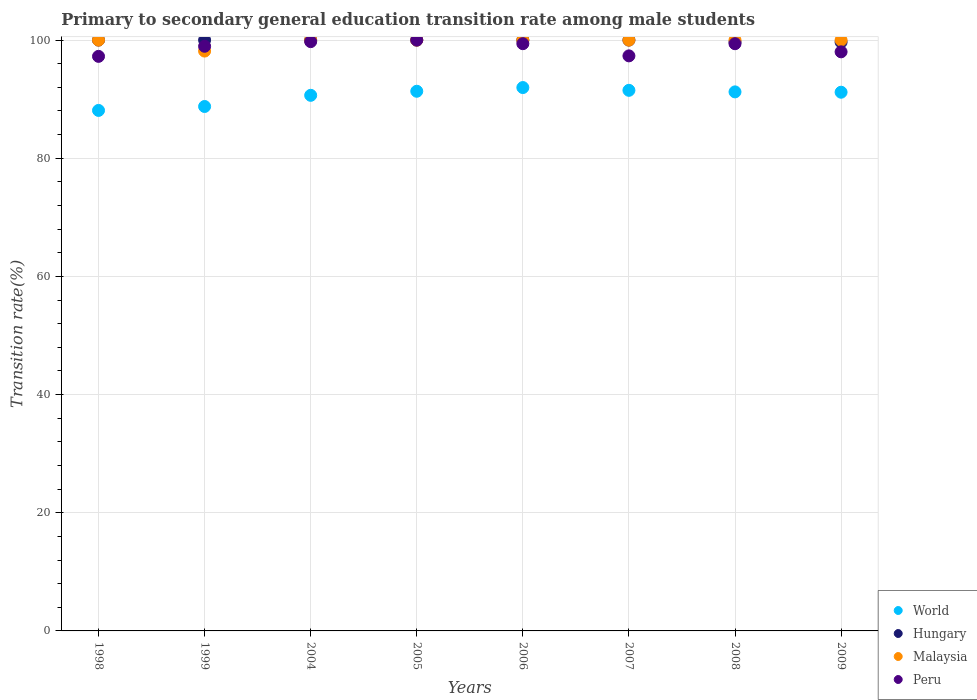Is the number of dotlines equal to the number of legend labels?
Offer a very short reply. Yes. Across all years, what is the maximum transition rate in World?
Your response must be concise. 91.97. Across all years, what is the minimum transition rate in World?
Your answer should be very brief. 88.1. What is the total transition rate in Malaysia in the graph?
Your answer should be very brief. 798.14. What is the difference between the transition rate in Hungary in 1998 and that in 2009?
Your answer should be compact. 0.35. What is the difference between the transition rate in Malaysia in 2007 and the transition rate in Hungary in 2008?
Keep it short and to the point. 0.32. What is the average transition rate in Hungary per year?
Provide a short and direct response. 99.92. In the year 2004, what is the difference between the transition rate in World and transition rate in Malaysia?
Provide a short and direct response. -9.35. In how many years, is the transition rate in World greater than 40 %?
Keep it short and to the point. 8. What is the ratio of the transition rate in Hungary in 1998 to that in 2009?
Offer a very short reply. 1. Is the difference between the transition rate in World in 2004 and 2006 greater than the difference between the transition rate in Malaysia in 2004 and 2006?
Your answer should be very brief. No. What is the difference between the highest and the second highest transition rate in Peru?
Make the answer very short. 0.26. What is the difference between the highest and the lowest transition rate in World?
Make the answer very short. 3.87. Is it the case that in every year, the sum of the transition rate in Peru and transition rate in Malaysia  is greater than the sum of transition rate in Hungary and transition rate in World?
Give a very brief answer. No. Is the transition rate in World strictly greater than the transition rate in Malaysia over the years?
Your answer should be very brief. No. How many dotlines are there?
Ensure brevity in your answer.  4. How many years are there in the graph?
Your answer should be compact. 8. Does the graph contain any zero values?
Provide a succinct answer. No. Does the graph contain grids?
Ensure brevity in your answer.  Yes. Where does the legend appear in the graph?
Offer a very short reply. Bottom right. What is the title of the graph?
Provide a short and direct response. Primary to secondary general education transition rate among male students. What is the label or title of the X-axis?
Your response must be concise. Years. What is the label or title of the Y-axis?
Provide a succinct answer. Transition rate(%). What is the Transition rate(%) of World in 1998?
Your answer should be very brief. 88.1. What is the Transition rate(%) in Peru in 1998?
Make the answer very short. 97.25. What is the Transition rate(%) of World in 1999?
Keep it short and to the point. 88.76. What is the Transition rate(%) in Malaysia in 1999?
Offer a terse response. 98.14. What is the Transition rate(%) of Peru in 1999?
Your response must be concise. 98.95. What is the Transition rate(%) in World in 2004?
Your answer should be very brief. 90.65. What is the Transition rate(%) in Hungary in 2004?
Make the answer very short. 100. What is the Transition rate(%) of Malaysia in 2004?
Your answer should be very brief. 100. What is the Transition rate(%) in Peru in 2004?
Your answer should be compact. 99.74. What is the Transition rate(%) in World in 2005?
Provide a short and direct response. 91.34. What is the Transition rate(%) in Malaysia in 2005?
Your response must be concise. 100. What is the Transition rate(%) of Peru in 2005?
Your answer should be very brief. 100. What is the Transition rate(%) of World in 2006?
Offer a very short reply. 91.97. What is the Transition rate(%) in Peru in 2006?
Make the answer very short. 99.39. What is the Transition rate(%) of World in 2007?
Your answer should be compact. 91.5. What is the Transition rate(%) in Hungary in 2007?
Your response must be concise. 100. What is the Transition rate(%) of Malaysia in 2007?
Give a very brief answer. 100. What is the Transition rate(%) in Peru in 2007?
Ensure brevity in your answer.  97.33. What is the Transition rate(%) of World in 2008?
Your answer should be compact. 91.23. What is the Transition rate(%) of Hungary in 2008?
Provide a short and direct response. 99.68. What is the Transition rate(%) in Peru in 2008?
Offer a terse response. 99.39. What is the Transition rate(%) of World in 2009?
Your answer should be very brief. 91.18. What is the Transition rate(%) of Hungary in 2009?
Give a very brief answer. 99.65. What is the Transition rate(%) of Malaysia in 2009?
Your response must be concise. 100. What is the Transition rate(%) of Peru in 2009?
Your answer should be compact. 98.01. Across all years, what is the maximum Transition rate(%) of World?
Offer a very short reply. 91.97. Across all years, what is the minimum Transition rate(%) of World?
Your answer should be very brief. 88.1. Across all years, what is the minimum Transition rate(%) in Hungary?
Provide a short and direct response. 99.65. Across all years, what is the minimum Transition rate(%) of Malaysia?
Ensure brevity in your answer.  98.14. Across all years, what is the minimum Transition rate(%) in Peru?
Your response must be concise. 97.25. What is the total Transition rate(%) in World in the graph?
Ensure brevity in your answer.  724.72. What is the total Transition rate(%) in Hungary in the graph?
Your answer should be compact. 799.33. What is the total Transition rate(%) in Malaysia in the graph?
Your answer should be very brief. 798.14. What is the total Transition rate(%) in Peru in the graph?
Keep it short and to the point. 790.06. What is the difference between the Transition rate(%) of World in 1998 and that in 1999?
Ensure brevity in your answer.  -0.67. What is the difference between the Transition rate(%) in Malaysia in 1998 and that in 1999?
Offer a very short reply. 1.86. What is the difference between the Transition rate(%) in Peru in 1998 and that in 1999?
Provide a short and direct response. -1.71. What is the difference between the Transition rate(%) in World in 1998 and that in 2004?
Offer a very short reply. -2.56. What is the difference between the Transition rate(%) in Peru in 1998 and that in 2004?
Provide a short and direct response. -2.49. What is the difference between the Transition rate(%) in World in 1998 and that in 2005?
Offer a very short reply. -3.24. What is the difference between the Transition rate(%) in Hungary in 1998 and that in 2005?
Ensure brevity in your answer.  0. What is the difference between the Transition rate(%) in Malaysia in 1998 and that in 2005?
Keep it short and to the point. 0. What is the difference between the Transition rate(%) in Peru in 1998 and that in 2005?
Offer a terse response. -2.75. What is the difference between the Transition rate(%) in World in 1998 and that in 2006?
Offer a terse response. -3.87. What is the difference between the Transition rate(%) of Peru in 1998 and that in 2006?
Give a very brief answer. -2.15. What is the difference between the Transition rate(%) of World in 1998 and that in 2007?
Ensure brevity in your answer.  -3.4. What is the difference between the Transition rate(%) in Hungary in 1998 and that in 2007?
Provide a succinct answer. 0. What is the difference between the Transition rate(%) of Peru in 1998 and that in 2007?
Your answer should be very brief. -0.08. What is the difference between the Transition rate(%) of World in 1998 and that in 2008?
Your answer should be very brief. -3.14. What is the difference between the Transition rate(%) in Hungary in 1998 and that in 2008?
Offer a very short reply. 0.32. What is the difference between the Transition rate(%) of Peru in 1998 and that in 2008?
Provide a succinct answer. -2.14. What is the difference between the Transition rate(%) in World in 1998 and that in 2009?
Your answer should be very brief. -3.08. What is the difference between the Transition rate(%) in Hungary in 1998 and that in 2009?
Give a very brief answer. 0.35. What is the difference between the Transition rate(%) of Peru in 1998 and that in 2009?
Your answer should be very brief. -0.77. What is the difference between the Transition rate(%) in World in 1999 and that in 2004?
Provide a succinct answer. -1.89. What is the difference between the Transition rate(%) in Malaysia in 1999 and that in 2004?
Ensure brevity in your answer.  -1.86. What is the difference between the Transition rate(%) of Peru in 1999 and that in 2004?
Provide a succinct answer. -0.79. What is the difference between the Transition rate(%) in World in 1999 and that in 2005?
Make the answer very short. -2.58. What is the difference between the Transition rate(%) in Malaysia in 1999 and that in 2005?
Provide a succinct answer. -1.86. What is the difference between the Transition rate(%) in Peru in 1999 and that in 2005?
Make the answer very short. -1.05. What is the difference between the Transition rate(%) of World in 1999 and that in 2006?
Keep it short and to the point. -3.2. What is the difference between the Transition rate(%) of Hungary in 1999 and that in 2006?
Ensure brevity in your answer.  0. What is the difference between the Transition rate(%) of Malaysia in 1999 and that in 2006?
Offer a very short reply. -1.86. What is the difference between the Transition rate(%) in Peru in 1999 and that in 2006?
Provide a short and direct response. -0.44. What is the difference between the Transition rate(%) in World in 1999 and that in 2007?
Ensure brevity in your answer.  -2.74. What is the difference between the Transition rate(%) in Hungary in 1999 and that in 2007?
Offer a terse response. 0. What is the difference between the Transition rate(%) in Malaysia in 1999 and that in 2007?
Your answer should be compact. -1.86. What is the difference between the Transition rate(%) of Peru in 1999 and that in 2007?
Provide a succinct answer. 1.62. What is the difference between the Transition rate(%) in World in 1999 and that in 2008?
Your answer should be compact. -2.47. What is the difference between the Transition rate(%) of Hungary in 1999 and that in 2008?
Your answer should be compact. 0.32. What is the difference between the Transition rate(%) in Malaysia in 1999 and that in 2008?
Keep it short and to the point. -1.86. What is the difference between the Transition rate(%) in Peru in 1999 and that in 2008?
Your response must be concise. -0.43. What is the difference between the Transition rate(%) in World in 1999 and that in 2009?
Your response must be concise. -2.41. What is the difference between the Transition rate(%) in Hungary in 1999 and that in 2009?
Keep it short and to the point. 0.35. What is the difference between the Transition rate(%) in Malaysia in 1999 and that in 2009?
Keep it short and to the point. -1.86. What is the difference between the Transition rate(%) of Peru in 1999 and that in 2009?
Your response must be concise. 0.94. What is the difference between the Transition rate(%) of World in 2004 and that in 2005?
Make the answer very short. -0.69. What is the difference between the Transition rate(%) of Hungary in 2004 and that in 2005?
Make the answer very short. 0. What is the difference between the Transition rate(%) of Malaysia in 2004 and that in 2005?
Provide a short and direct response. 0. What is the difference between the Transition rate(%) of Peru in 2004 and that in 2005?
Ensure brevity in your answer.  -0.26. What is the difference between the Transition rate(%) of World in 2004 and that in 2006?
Your answer should be compact. -1.31. What is the difference between the Transition rate(%) in Malaysia in 2004 and that in 2006?
Your answer should be compact. 0. What is the difference between the Transition rate(%) in Peru in 2004 and that in 2006?
Offer a terse response. 0.35. What is the difference between the Transition rate(%) of World in 2004 and that in 2007?
Give a very brief answer. -0.85. What is the difference between the Transition rate(%) in Hungary in 2004 and that in 2007?
Offer a terse response. 0. What is the difference between the Transition rate(%) of Malaysia in 2004 and that in 2007?
Offer a terse response. 0. What is the difference between the Transition rate(%) in Peru in 2004 and that in 2007?
Give a very brief answer. 2.41. What is the difference between the Transition rate(%) of World in 2004 and that in 2008?
Provide a succinct answer. -0.58. What is the difference between the Transition rate(%) in Hungary in 2004 and that in 2008?
Make the answer very short. 0.32. What is the difference between the Transition rate(%) of Malaysia in 2004 and that in 2008?
Provide a succinct answer. 0. What is the difference between the Transition rate(%) of Peru in 2004 and that in 2008?
Offer a very short reply. 0.35. What is the difference between the Transition rate(%) of World in 2004 and that in 2009?
Make the answer very short. -0.53. What is the difference between the Transition rate(%) in Hungary in 2004 and that in 2009?
Your response must be concise. 0.35. What is the difference between the Transition rate(%) of Peru in 2004 and that in 2009?
Make the answer very short. 1.73. What is the difference between the Transition rate(%) in World in 2005 and that in 2006?
Your answer should be compact. -0.63. What is the difference between the Transition rate(%) of Peru in 2005 and that in 2006?
Offer a very short reply. 0.61. What is the difference between the Transition rate(%) of World in 2005 and that in 2007?
Provide a short and direct response. -0.16. What is the difference between the Transition rate(%) of Hungary in 2005 and that in 2007?
Your answer should be very brief. 0. What is the difference between the Transition rate(%) in Peru in 2005 and that in 2007?
Make the answer very short. 2.67. What is the difference between the Transition rate(%) of World in 2005 and that in 2008?
Make the answer very short. 0.11. What is the difference between the Transition rate(%) in Hungary in 2005 and that in 2008?
Your response must be concise. 0.32. What is the difference between the Transition rate(%) of Malaysia in 2005 and that in 2008?
Your answer should be compact. 0. What is the difference between the Transition rate(%) of Peru in 2005 and that in 2008?
Offer a very short reply. 0.61. What is the difference between the Transition rate(%) of World in 2005 and that in 2009?
Give a very brief answer. 0.16. What is the difference between the Transition rate(%) in Hungary in 2005 and that in 2009?
Your answer should be very brief. 0.35. What is the difference between the Transition rate(%) in Peru in 2005 and that in 2009?
Provide a succinct answer. 1.99. What is the difference between the Transition rate(%) in World in 2006 and that in 2007?
Provide a short and direct response. 0.47. What is the difference between the Transition rate(%) of Malaysia in 2006 and that in 2007?
Make the answer very short. 0. What is the difference between the Transition rate(%) in Peru in 2006 and that in 2007?
Your answer should be very brief. 2.06. What is the difference between the Transition rate(%) of World in 2006 and that in 2008?
Make the answer very short. 0.73. What is the difference between the Transition rate(%) of Hungary in 2006 and that in 2008?
Give a very brief answer. 0.32. What is the difference between the Transition rate(%) in Malaysia in 2006 and that in 2008?
Your answer should be very brief. 0. What is the difference between the Transition rate(%) of Peru in 2006 and that in 2008?
Provide a succinct answer. 0. What is the difference between the Transition rate(%) of World in 2006 and that in 2009?
Your response must be concise. 0.79. What is the difference between the Transition rate(%) in Hungary in 2006 and that in 2009?
Ensure brevity in your answer.  0.35. What is the difference between the Transition rate(%) of Malaysia in 2006 and that in 2009?
Your answer should be very brief. 0. What is the difference between the Transition rate(%) in Peru in 2006 and that in 2009?
Provide a succinct answer. 1.38. What is the difference between the Transition rate(%) in World in 2007 and that in 2008?
Offer a very short reply. 0.26. What is the difference between the Transition rate(%) of Hungary in 2007 and that in 2008?
Provide a succinct answer. 0.32. What is the difference between the Transition rate(%) of Peru in 2007 and that in 2008?
Provide a short and direct response. -2.06. What is the difference between the Transition rate(%) in World in 2007 and that in 2009?
Your response must be concise. 0.32. What is the difference between the Transition rate(%) in Hungary in 2007 and that in 2009?
Give a very brief answer. 0.35. What is the difference between the Transition rate(%) of Peru in 2007 and that in 2009?
Give a very brief answer. -0.68. What is the difference between the Transition rate(%) in World in 2008 and that in 2009?
Give a very brief answer. 0.06. What is the difference between the Transition rate(%) of Hungary in 2008 and that in 2009?
Offer a very short reply. 0.02. What is the difference between the Transition rate(%) of Malaysia in 2008 and that in 2009?
Offer a terse response. 0. What is the difference between the Transition rate(%) in Peru in 2008 and that in 2009?
Your answer should be compact. 1.38. What is the difference between the Transition rate(%) in World in 1998 and the Transition rate(%) in Hungary in 1999?
Provide a short and direct response. -11.9. What is the difference between the Transition rate(%) of World in 1998 and the Transition rate(%) of Malaysia in 1999?
Offer a very short reply. -10.04. What is the difference between the Transition rate(%) of World in 1998 and the Transition rate(%) of Peru in 1999?
Make the answer very short. -10.86. What is the difference between the Transition rate(%) in Hungary in 1998 and the Transition rate(%) in Malaysia in 1999?
Keep it short and to the point. 1.86. What is the difference between the Transition rate(%) in Hungary in 1998 and the Transition rate(%) in Peru in 1999?
Keep it short and to the point. 1.05. What is the difference between the Transition rate(%) in Malaysia in 1998 and the Transition rate(%) in Peru in 1999?
Make the answer very short. 1.05. What is the difference between the Transition rate(%) in World in 1998 and the Transition rate(%) in Hungary in 2004?
Give a very brief answer. -11.9. What is the difference between the Transition rate(%) in World in 1998 and the Transition rate(%) in Malaysia in 2004?
Your response must be concise. -11.9. What is the difference between the Transition rate(%) in World in 1998 and the Transition rate(%) in Peru in 2004?
Provide a short and direct response. -11.64. What is the difference between the Transition rate(%) in Hungary in 1998 and the Transition rate(%) in Peru in 2004?
Offer a very short reply. 0.26. What is the difference between the Transition rate(%) of Malaysia in 1998 and the Transition rate(%) of Peru in 2004?
Your answer should be compact. 0.26. What is the difference between the Transition rate(%) in World in 1998 and the Transition rate(%) in Hungary in 2005?
Your answer should be compact. -11.9. What is the difference between the Transition rate(%) of World in 1998 and the Transition rate(%) of Malaysia in 2005?
Ensure brevity in your answer.  -11.9. What is the difference between the Transition rate(%) of World in 1998 and the Transition rate(%) of Peru in 2005?
Your response must be concise. -11.9. What is the difference between the Transition rate(%) of Hungary in 1998 and the Transition rate(%) of Malaysia in 2005?
Make the answer very short. 0. What is the difference between the Transition rate(%) of Hungary in 1998 and the Transition rate(%) of Peru in 2005?
Provide a succinct answer. 0. What is the difference between the Transition rate(%) in World in 1998 and the Transition rate(%) in Hungary in 2006?
Provide a succinct answer. -11.9. What is the difference between the Transition rate(%) in World in 1998 and the Transition rate(%) in Malaysia in 2006?
Your answer should be very brief. -11.9. What is the difference between the Transition rate(%) in World in 1998 and the Transition rate(%) in Peru in 2006?
Your answer should be compact. -11.3. What is the difference between the Transition rate(%) of Hungary in 1998 and the Transition rate(%) of Malaysia in 2006?
Ensure brevity in your answer.  0. What is the difference between the Transition rate(%) of Hungary in 1998 and the Transition rate(%) of Peru in 2006?
Ensure brevity in your answer.  0.61. What is the difference between the Transition rate(%) of Malaysia in 1998 and the Transition rate(%) of Peru in 2006?
Keep it short and to the point. 0.61. What is the difference between the Transition rate(%) of World in 1998 and the Transition rate(%) of Hungary in 2007?
Provide a short and direct response. -11.9. What is the difference between the Transition rate(%) of World in 1998 and the Transition rate(%) of Malaysia in 2007?
Your answer should be very brief. -11.9. What is the difference between the Transition rate(%) in World in 1998 and the Transition rate(%) in Peru in 2007?
Your response must be concise. -9.23. What is the difference between the Transition rate(%) of Hungary in 1998 and the Transition rate(%) of Peru in 2007?
Your answer should be very brief. 2.67. What is the difference between the Transition rate(%) in Malaysia in 1998 and the Transition rate(%) in Peru in 2007?
Offer a very short reply. 2.67. What is the difference between the Transition rate(%) in World in 1998 and the Transition rate(%) in Hungary in 2008?
Provide a succinct answer. -11.58. What is the difference between the Transition rate(%) of World in 1998 and the Transition rate(%) of Malaysia in 2008?
Your answer should be compact. -11.9. What is the difference between the Transition rate(%) in World in 1998 and the Transition rate(%) in Peru in 2008?
Make the answer very short. -11.29. What is the difference between the Transition rate(%) of Hungary in 1998 and the Transition rate(%) of Peru in 2008?
Give a very brief answer. 0.61. What is the difference between the Transition rate(%) of Malaysia in 1998 and the Transition rate(%) of Peru in 2008?
Your answer should be very brief. 0.61. What is the difference between the Transition rate(%) of World in 1998 and the Transition rate(%) of Hungary in 2009?
Provide a succinct answer. -11.56. What is the difference between the Transition rate(%) of World in 1998 and the Transition rate(%) of Malaysia in 2009?
Your response must be concise. -11.9. What is the difference between the Transition rate(%) of World in 1998 and the Transition rate(%) of Peru in 2009?
Make the answer very short. -9.92. What is the difference between the Transition rate(%) in Hungary in 1998 and the Transition rate(%) in Peru in 2009?
Offer a very short reply. 1.99. What is the difference between the Transition rate(%) of Malaysia in 1998 and the Transition rate(%) of Peru in 2009?
Provide a short and direct response. 1.99. What is the difference between the Transition rate(%) of World in 1999 and the Transition rate(%) of Hungary in 2004?
Offer a terse response. -11.24. What is the difference between the Transition rate(%) in World in 1999 and the Transition rate(%) in Malaysia in 2004?
Ensure brevity in your answer.  -11.24. What is the difference between the Transition rate(%) in World in 1999 and the Transition rate(%) in Peru in 2004?
Your answer should be very brief. -10.98. What is the difference between the Transition rate(%) of Hungary in 1999 and the Transition rate(%) of Peru in 2004?
Provide a short and direct response. 0.26. What is the difference between the Transition rate(%) in Malaysia in 1999 and the Transition rate(%) in Peru in 2004?
Provide a succinct answer. -1.6. What is the difference between the Transition rate(%) of World in 1999 and the Transition rate(%) of Hungary in 2005?
Your answer should be compact. -11.24. What is the difference between the Transition rate(%) in World in 1999 and the Transition rate(%) in Malaysia in 2005?
Make the answer very short. -11.24. What is the difference between the Transition rate(%) in World in 1999 and the Transition rate(%) in Peru in 2005?
Provide a succinct answer. -11.24. What is the difference between the Transition rate(%) of Malaysia in 1999 and the Transition rate(%) of Peru in 2005?
Provide a succinct answer. -1.86. What is the difference between the Transition rate(%) of World in 1999 and the Transition rate(%) of Hungary in 2006?
Give a very brief answer. -11.24. What is the difference between the Transition rate(%) of World in 1999 and the Transition rate(%) of Malaysia in 2006?
Keep it short and to the point. -11.24. What is the difference between the Transition rate(%) of World in 1999 and the Transition rate(%) of Peru in 2006?
Ensure brevity in your answer.  -10.63. What is the difference between the Transition rate(%) in Hungary in 1999 and the Transition rate(%) in Malaysia in 2006?
Give a very brief answer. 0. What is the difference between the Transition rate(%) in Hungary in 1999 and the Transition rate(%) in Peru in 2006?
Keep it short and to the point. 0.61. What is the difference between the Transition rate(%) of Malaysia in 1999 and the Transition rate(%) of Peru in 2006?
Your answer should be very brief. -1.25. What is the difference between the Transition rate(%) in World in 1999 and the Transition rate(%) in Hungary in 2007?
Your response must be concise. -11.24. What is the difference between the Transition rate(%) of World in 1999 and the Transition rate(%) of Malaysia in 2007?
Make the answer very short. -11.24. What is the difference between the Transition rate(%) in World in 1999 and the Transition rate(%) in Peru in 2007?
Your answer should be very brief. -8.57. What is the difference between the Transition rate(%) in Hungary in 1999 and the Transition rate(%) in Peru in 2007?
Provide a short and direct response. 2.67. What is the difference between the Transition rate(%) of Malaysia in 1999 and the Transition rate(%) of Peru in 2007?
Ensure brevity in your answer.  0.81. What is the difference between the Transition rate(%) of World in 1999 and the Transition rate(%) of Hungary in 2008?
Provide a short and direct response. -10.91. What is the difference between the Transition rate(%) of World in 1999 and the Transition rate(%) of Malaysia in 2008?
Ensure brevity in your answer.  -11.24. What is the difference between the Transition rate(%) in World in 1999 and the Transition rate(%) in Peru in 2008?
Your response must be concise. -10.63. What is the difference between the Transition rate(%) in Hungary in 1999 and the Transition rate(%) in Malaysia in 2008?
Ensure brevity in your answer.  0. What is the difference between the Transition rate(%) in Hungary in 1999 and the Transition rate(%) in Peru in 2008?
Your answer should be very brief. 0.61. What is the difference between the Transition rate(%) of Malaysia in 1999 and the Transition rate(%) of Peru in 2008?
Offer a very short reply. -1.25. What is the difference between the Transition rate(%) of World in 1999 and the Transition rate(%) of Hungary in 2009?
Offer a terse response. -10.89. What is the difference between the Transition rate(%) in World in 1999 and the Transition rate(%) in Malaysia in 2009?
Make the answer very short. -11.24. What is the difference between the Transition rate(%) in World in 1999 and the Transition rate(%) in Peru in 2009?
Offer a terse response. -9.25. What is the difference between the Transition rate(%) of Hungary in 1999 and the Transition rate(%) of Malaysia in 2009?
Offer a very short reply. 0. What is the difference between the Transition rate(%) in Hungary in 1999 and the Transition rate(%) in Peru in 2009?
Your response must be concise. 1.99. What is the difference between the Transition rate(%) in Malaysia in 1999 and the Transition rate(%) in Peru in 2009?
Offer a very short reply. 0.13. What is the difference between the Transition rate(%) in World in 2004 and the Transition rate(%) in Hungary in 2005?
Give a very brief answer. -9.35. What is the difference between the Transition rate(%) of World in 2004 and the Transition rate(%) of Malaysia in 2005?
Offer a terse response. -9.35. What is the difference between the Transition rate(%) of World in 2004 and the Transition rate(%) of Peru in 2005?
Provide a succinct answer. -9.35. What is the difference between the Transition rate(%) in Hungary in 2004 and the Transition rate(%) in Peru in 2005?
Provide a short and direct response. 0. What is the difference between the Transition rate(%) in World in 2004 and the Transition rate(%) in Hungary in 2006?
Your answer should be compact. -9.35. What is the difference between the Transition rate(%) in World in 2004 and the Transition rate(%) in Malaysia in 2006?
Provide a short and direct response. -9.35. What is the difference between the Transition rate(%) in World in 2004 and the Transition rate(%) in Peru in 2006?
Provide a short and direct response. -8.74. What is the difference between the Transition rate(%) in Hungary in 2004 and the Transition rate(%) in Malaysia in 2006?
Offer a terse response. 0. What is the difference between the Transition rate(%) in Hungary in 2004 and the Transition rate(%) in Peru in 2006?
Provide a succinct answer. 0.61. What is the difference between the Transition rate(%) in Malaysia in 2004 and the Transition rate(%) in Peru in 2006?
Make the answer very short. 0.61. What is the difference between the Transition rate(%) of World in 2004 and the Transition rate(%) of Hungary in 2007?
Your response must be concise. -9.35. What is the difference between the Transition rate(%) of World in 2004 and the Transition rate(%) of Malaysia in 2007?
Give a very brief answer. -9.35. What is the difference between the Transition rate(%) in World in 2004 and the Transition rate(%) in Peru in 2007?
Your answer should be compact. -6.68. What is the difference between the Transition rate(%) of Hungary in 2004 and the Transition rate(%) of Peru in 2007?
Your answer should be very brief. 2.67. What is the difference between the Transition rate(%) in Malaysia in 2004 and the Transition rate(%) in Peru in 2007?
Provide a short and direct response. 2.67. What is the difference between the Transition rate(%) in World in 2004 and the Transition rate(%) in Hungary in 2008?
Make the answer very short. -9.02. What is the difference between the Transition rate(%) in World in 2004 and the Transition rate(%) in Malaysia in 2008?
Make the answer very short. -9.35. What is the difference between the Transition rate(%) in World in 2004 and the Transition rate(%) in Peru in 2008?
Offer a very short reply. -8.74. What is the difference between the Transition rate(%) in Hungary in 2004 and the Transition rate(%) in Malaysia in 2008?
Provide a succinct answer. 0. What is the difference between the Transition rate(%) of Hungary in 2004 and the Transition rate(%) of Peru in 2008?
Your response must be concise. 0.61. What is the difference between the Transition rate(%) of Malaysia in 2004 and the Transition rate(%) of Peru in 2008?
Your response must be concise. 0.61. What is the difference between the Transition rate(%) in World in 2004 and the Transition rate(%) in Hungary in 2009?
Your answer should be compact. -9. What is the difference between the Transition rate(%) in World in 2004 and the Transition rate(%) in Malaysia in 2009?
Your response must be concise. -9.35. What is the difference between the Transition rate(%) in World in 2004 and the Transition rate(%) in Peru in 2009?
Provide a succinct answer. -7.36. What is the difference between the Transition rate(%) of Hungary in 2004 and the Transition rate(%) of Malaysia in 2009?
Your answer should be compact. 0. What is the difference between the Transition rate(%) in Hungary in 2004 and the Transition rate(%) in Peru in 2009?
Ensure brevity in your answer.  1.99. What is the difference between the Transition rate(%) in Malaysia in 2004 and the Transition rate(%) in Peru in 2009?
Offer a very short reply. 1.99. What is the difference between the Transition rate(%) in World in 2005 and the Transition rate(%) in Hungary in 2006?
Keep it short and to the point. -8.66. What is the difference between the Transition rate(%) in World in 2005 and the Transition rate(%) in Malaysia in 2006?
Provide a short and direct response. -8.66. What is the difference between the Transition rate(%) of World in 2005 and the Transition rate(%) of Peru in 2006?
Offer a very short reply. -8.05. What is the difference between the Transition rate(%) in Hungary in 2005 and the Transition rate(%) in Malaysia in 2006?
Your response must be concise. 0. What is the difference between the Transition rate(%) in Hungary in 2005 and the Transition rate(%) in Peru in 2006?
Provide a short and direct response. 0.61. What is the difference between the Transition rate(%) in Malaysia in 2005 and the Transition rate(%) in Peru in 2006?
Offer a terse response. 0.61. What is the difference between the Transition rate(%) in World in 2005 and the Transition rate(%) in Hungary in 2007?
Your answer should be very brief. -8.66. What is the difference between the Transition rate(%) of World in 2005 and the Transition rate(%) of Malaysia in 2007?
Your answer should be compact. -8.66. What is the difference between the Transition rate(%) in World in 2005 and the Transition rate(%) in Peru in 2007?
Your response must be concise. -5.99. What is the difference between the Transition rate(%) of Hungary in 2005 and the Transition rate(%) of Peru in 2007?
Keep it short and to the point. 2.67. What is the difference between the Transition rate(%) of Malaysia in 2005 and the Transition rate(%) of Peru in 2007?
Keep it short and to the point. 2.67. What is the difference between the Transition rate(%) of World in 2005 and the Transition rate(%) of Hungary in 2008?
Provide a short and direct response. -8.34. What is the difference between the Transition rate(%) in World in 2005 and the Transition rate(%) in Malaysia in 2008?
Your answer should be very brief. -8.66. What is the difference between the Transition rate(%) in World in 2005 and the Transition rate(%) in Peru in 2008?
Ensure brevity in your answer.  -8.05. What is the difference between the Transition rate(%) in Hungary in 2005 and the Transition rate(%) in Peru in 2008?
Make the answer very short. 0.61. What is the difference between the Transition rate(%) in Malaysia in 2005 and the Transition rate(%) in Peru in 2008?
Your answer should be compact. 0.61. What is the difference between the Transition rate(%) in World in 2005 and the Transition rate(%) in Hungary in 2009?
Your response must be concise. -8.31. What is the difference between the Transition rate(%) in World in 2005 and the Transition rate(%) in Malaysia in 2009?
Keep it short and to the point. -8.66. What is the difference between the Transition rate(%) in World in 2005 and the Transition rate(%) in Peru in 2009?
Offer a terse response. -6.67. What is the difference between the Transition rate(%) of Hungary in 2005 and the Transition rate(%) of Malaysia in 2009?
Give a very brief answer. 0. What is the difference between the Transition rate(%) of Hungary in 2005 and the Transition rate(%) of Peru in 2009?
Offer a terse response. 1.99. What is the difference between the Transition rate(%) in Malaysia in 2005 and the Transition rate(%) in Peru in 2009?
Your answer should be compact. 1.99. What is the difference between the Transition rate(%) in World in 2006 and the Transition rate(%) in Hungary in 2007?
Make the answer very short. -8.03. What is the difference between the Transition rate(%) in World in 2006 and the Transition rate(%) in Malaysia in 2007?
Provide a short and direct response. -8.03. What is the difference between the Transition rate(%) in World in 2006 and the Transition rate(%) in Peru in 2007?
Your answer should be very brief. -5.36. What is the difference between the Transition rate(%) of Hungary in 2006 and the Transition rate(%) of Malaysia in 2007?
Give a very brief answer. 0. What is the difference between the Transition rate(%) of Hungary in 2006 and the Transition rate(%) of Peru in 2007?
Ensure brevity in your answer.  2.67. What is the difference between the Transition rate(%) in Malaysia in 2006 and the Transition rate(%) in Peru in 2007?
Your answer should be compact. 2.67. What is the difference between the Transition rate(%) of World in 2006 and the Transition rate(%) of Hungary in 2008?
Offer a very short reply. -7.71. What is the difference between the Transition rate(%) of World in 2006 and the Transition rate(%) of Malaysia in 2008?
Keep it short and to the point. -8.03. What is the difference between the Transition rate(%) of World in 2006 and the Transition rate(%) of Peru in 2008?
Ensure brevity in your answer.  -7.42. What is the difference between the Transition rate(%) of Hungary in 2006 and the Transition rate(%) of Peru in 2008?
Ensure brevity in your answer.  0.61. What is the difference between the Transition rate(%) of Malaysia in 2006 and the Transition rate(%) of Peru in 2008?
Provide a short and direct response. 0.61. What is the difference between the Transition rate(%) of World in 2006 and the Transition rate(%) of Hungary in 2009?
Your answer should be very brief. -7.69. What is the difference between the Transition rate(%) in World in 2006 and the Transition rate(%) in Malaysia in 2009?
Provide a succinct answer. -8.03. What is the difference between the Transition rate(%) of World in 2006 and the Transition rate(%) of Peru in 2009?
Your answer should be compact. -6.05. What is the difference between the Transition rate(%) in Hungary in 2006 and the Transition rate(%) in Malaysia in 2009?
Your answer should be compact. 0. What is the difference between the Transition rate(%) in Hungary in 2006 and the Transition rate(%) in Peru in 2009?
Your response must be concise. 1.99. What is the difference between the Transition rate(%) of Malaysia in 2006 and the Transition rate(%) of Peru in 2009?
Your answer should be very brief. 1.99. What is the difference between the Transition rate(%) of World in 2007 and the Transition rate(%) of Hungary in 2008?
Offer a very short reply. -8.18. What is the difference between the Transition rate(%) in World in 2007 and the Transition rate(%) in Malaysia in 2008?
Ensure brevity in your answer.  -8.5. What is the difference between the Transition rate(%) of World in 2007 and the Transition rate(%) of Peru in 2008?
Ensure brevity in your answer.  -7.89. What is the difference between the Transition rate(%) in Hungary in 2007 and the Transition rate(%) in Malaysia in 2008?
Provide a short and direct response. 0. What is the difference between the Transition rate(%) of Hungary in 2007 and the Transition rate(%) of Peru in 2008?
Give a very brief answer. 0.61. What is the difference between the Transition rate(%) in Malaysia in 2007 and the Transition rate(%) in Peru in 2008?
Offer a very short reply. 0.61. What is the difference between the Transition rate(%) of World in 2007 and the Transition rate(%) of Hungary in 2009?
Make the answer very short. -8.16. What is the difference between the Transition rate(%) of World in 2007 and the Transition rate(%) of Malaysia in 2009?
Provide a succinct answer. -8.5. What is the difference between the Transition rate(%) of World in 2007 and the Transition rate(%) of Peru in 2009?
Your answer should be compact. -6.51. What is the difference between the Transition rate(%) of Hungary in 2007 and the Transition rate(%) of Peru in 2009?
Provide a succinct answer. 1.99. What is the difference between the Transition rate(%) in Malaysia in 2007 and the Transition rate(%) in Peru in 2009?
Your response must be concise. 1.99. What is the difference between the Transition rate(%) of World in 2008 and the Transition rate(%) of Hungary in 2009?
Your answer should be compact. -8.42. What is the difference between the Transition rate(%) of World in 2008 and the Transition rate(%) of Malaysia in 2009?
Ensure brevity in your answer.  -8.77. What is the difference between the Transition rate(%) in World in 2008 and the Transition rate(%) in Peru in 2009?
Your answer should be very brief. -6.78. What is the difference between the Transition rate(%) of Hungary in 2008 and the Transition rate(%) of Malaysia in 2009?
Your answer should be compact. -0.32. What is the difference between the Transition rate(%) in Hungary in 2008 and the Transition rate(%) in Peru in 2009?
Your answer should be compact. 1.66. What is the difference between the Transition rate(%) of Malaysia in 2008 and the Transition rate(%) of Peru in 2009?
Offer a very short reply. 1.99. What is the average Transition rate(%) of World per year?
Give a very brief answer. 90.59. What is the average Transition rate(%) in Hungary per year?
Your response must be concise. 99.92. What is the average Transition rate(%) of Malaysia per year?
Offer a very short reply. 99.77. What is the average Transition rate(%) of Peru per year?
Your response must be concise. 98.76. In the year 1998, what is the difference between the Transition rate(%) in World and Transition rate(%) in Hungary?
Provide a succinct answer. -11.9. In the year 1998, what is the difference between the Transition rate(%) of World and Transition rate(%) of Malaysia?
Your response must be concise. -11.9. In the year 1998, what is the difference between the Transition rate(%) in World and Transition rate(%) in Peru?
Offer a very short reply. -9.15. In the year 1998, what is the difference between the Transition rate(%) of Hungary and Transition rate(%) of Malaysia?
Keep it short and to the point. 0. In the year 1998, what is the difference between the Transition rate(%) in Hungary and Transition rate(%) in Peru?
Provide a succinct answer. 2.75. In the year 1998, what is the difference between the Transition rate(%) of Malaysia and Transition rate(%) of Peru?
Give a very brief answer. 2.75. In the year 1999, what is the difference between the Transition rate(%) of World and Transition rate(%) of Hungary?
Provide a succinct answer. -11.24. In the year 1999, what is the difference between the Transition rate(%) of World and Transition rate(%) of Malaysia?
Keep it short and to the point. -9.38. In the year 1999, what is the difference between the Transition rate(%) in World and Transition rate(%) in Peru?
Your answer should be very brief. -10.19. In the year 1999, what is the difference between the Transition rate(%) of Hungary and Transition rate(%) of Malaysia?
Your response must be concise. 1.86. In the year 1999, what is the difference between the Transition rate(%) of Hungary and Transition rate(%) of Peru?
Provide a succinct answer. 1.05. In the year 1999, what is the difference between the Transition rate(%) in Malaysia and Transition rate(%) in Peru?
Make the answer very short. -0.81. In the year 2004, what is the difference between the Transition rate(%) of World and Transition rate(%) of Hungary?
Your answer should be compact. -9.35. In the year 2004, what is the difference between the Transition rate(%) of World and Transition rate(%) of Malaysia?
Offer a very short reply. -9.35. In the year 2004, what is the difference between the Transition rate(%) of World and Transition rate(%) of Peru?
Your answer should be very brief. -9.09. In the year 2004, what is the difference between the Transition rate(%) in Hungary and Transition rate(%) in Peru?
Provide a succinct answer. 0.26. In the year 2004, what is the difference between the Transition rate(%) in Malaysia and Transition rate(%) in Peru?
Offer a very short reply. 0.26. In the year 2005, what is the difference between the Transition rate(%) in World and Transition rate(%) in Hungary?
Keep it short and to the point. -8.66. In the year 2005, what is the difference between the Transition rate(%) of World and Transition rate(%) of Malaysia?
Provide a short and direct response. -8.66. In the year 2005, what is the difference between the Transition rate(%) in World and Transition rate(%) in Peru?
Make the answer very short. -8.66. In the year 2005, what is the difference between the Transition rate(%) of Hungary and Transition rate(%) of Peru?
Provide a succinct answer. 0. In the year 2005, what is the difference between the Transition rate(%) in Malaysia and Transition rate(%) in Peru?
Your answer should be very brief. 0. In the year 2006, what is the difference between the Transition rate(%) of World and Transition rate(%) of Hungary?
Make the answer very short. -8.03. In the year 2006, what is the difference between the Transition rate(%) of World and Transition rate(%) of Malaysia?
Your answer should be compact. -8.03. In the year 2006, what is the difference between the Transition rate(%) of World and Transition rate(%) of Peru?
Keep it short and to the point. -7.43. In the year 2006, what is the difference between the Transition rate(%) in Hungary and Transition rate(%) in Peru?
Your answer should be very brief. 0.61. In the year 2006, what is the difference between the Transition rate(%) in Malaysia and Transition rate(%) in Peru?
Provide a short and direct response. 0.61. In the year 2007, what is the difference between the Transition rate(%) of World and Transition rate(%) of Hungary?
Offer a terse response. -8.5. In the year 2007, what is the difference between the Transition rate(%) of World and Transition rate(%) of Malaysia?
Ensure brevity in your answer.  -8.5. In the year 2007, what is the difference between the Transition rate(%) of World and Transition rate(%) of Peru?
Keep it short and to the point. -5.83. In the year 2007, what is the difference between the Transition rate(%) in Hungary and Transition rate(%) in Peru?
Your response must be concise. 2.67. In the year 2007, what is the difference between the Transition rate(%) of Malaysia and Transition rate(%) of Peru?
Your response must be concise. 2.67. In the year 2008, what is the difference between the Transition rate(%) in World and Transition rate(%) in Hungary?
Provide a short and direct response. -8.44. In the year 2008, what is the difference between the Transition rate(%) in World and Transition rate(%) in Malaysia?
Offer a very short reply. -8.77. In the year 2008, what is the difference between the Transition rate(%) in World and Transition rate(%) in Peru?
Your answer should be compact. -8.15. In the year 2008, what is the difference between the Transition rate(%) in Hungary and Transition rate(%) in Malaysia?
Your response must be concise. -0.32. In the year 2008, what is the difference between the Transition rate(%) in Hungary and Transition rate(%) in Peru?
Your response must be concise. 0.29. In the year 2008, what is the difference between the Transition rate(%) in Malaysia and Transition rate(%) in Peru?
Your answer should be compact. 0.61. In the year 2009, what is the difference between the Transition rate(%) in World and Transition rate(%) in Hungary?
Keep it short and to the point. -8.48. In the year 2009, what is the difference between the Transition rate(%) of World and Transition rate(%) of Malaysia?
Provide a short and direct response. -8.82. In the year 2009, what is the difference between the Transition rate(%) in World and Transition rate(%) in Peru?
Give a very brief answer. -6.84. In the year 2009, what is the difference between the Transition rate(%) of Hungary and Transition rate(%) of Malaysia?
Give a very brief answer. -0.35. In the year 2009, what is the difference between the Transition rate(%) of Hungary and Transition rate(%) of Peru?
Your response must be concise. 1.64. In the year 2009, what is the difference between the Transition rate(%) in Malaysia and Transition rate(%) in Peru?
Offer a terse response. 1.99. What is the ratio of the Transition rate(%) of World in 1998 to that in 1999?
Provide a short and direct response. 0.99. What is the ratio of the Transition rate(%) in Malaysia in 1998 to that in 1999?
Provide a short and direct response. 1.02. What is the ratio of the Transition rate(%) of Peru in 1998 to that in 1999?
Offer a very short reply. 0.98. What is the ratio of the Transition rate(%) of World in 1998 to that in 2004?
Keep it short and to the point. 0.97. What is the ratio of the Transition rate(%) of Hungary in 1998 to that in 2004?
Your response must be concise. 1. What is the ratio of the Transition rate(%) of Malaysia in 1998 to that in 2004?
Your response must be concise. 1. What is the ratio of the Transition rate(%) of World in 1998 to that in 2005?
Offer a very short reply. 0.96. What is the ratio of the Transition rate(%) of Hungary in 1998 to that in 2005?
Keep it short and to the point. 1. What is the ratio of the Transition rate(%) in Malaysia in 1998 to that in 2005?
Give a very brief answer. 1. What is the ratio of the Transition rate(%) in Peru in 1998 to that in 2005?
Offer a terse response. 0.97. What is the ratio of the Transition rate(%) in World in 1998 to that in 2006?
Keep it short and to the point. 0.96. What is the ratio of the Transition rate(%) in Malaysia in 1998 to that in 2006?
Offer a very short reply. 1. What is the ratio of the Transition rate(%) in Peru in 1998 to that in 2006?
Give a very brief answer. 0.98. What is the ratio of the Transition rate(%) of World in 1998 to that in 2007?
Provide a succinct answer. 0.96. What is the ratio of the Transition rate(%) in Malaysia in 1998 to that in 2007?
Your answer should be compact. 1. What is the ratio of the Transition rate(%) of Peru in 1998 to that in 2007?
Give a very brief answer. 1. What is the ratio of the Transition rate(%) of World in 1998 to that in 2008?
Provide a succinct answer. 0.97. What is the ratio of the Transition rate(%) in Hungary in 1998 to that in 2008?
Make the answer very short. 1. What is the ratio of the Transition rate(%) of Peru in 1998 to that in 2008?
Provide a succinct answer. 0.98. What is the ratio of the Transition rate(%) in World in 1998 to that in 2009?
Provide a succinct answer. 0.97. What is the ratio of the Transition rate(%) in Hungary in 1998 to that in 2009?
Make the answer very short. 1. What is the ratio of the Transition rate(%) in Peru in 1998 to that in 2009?
Provide a short and direct response. 0.99. What is the ratio of the Transition rate(%) in World in 1999 to that in 2004?
Offer a terse response. 0.98. What is the ratio of the Transition rate(%) of Hungary in 1999 to that in 2004?
Keep it short and to the point. 1. What is the ratio of the Transition rate(%) of Malaysia in 1999 to that in 2004?
Your answer should be very brief. 0.98. What is the ratio of the Transition rate(%) in World in 1999 to that in 2005?
Your answer should be compact. 0.97. What is the ratio of the Transition rate(%) of Hungary in 1999 to that in 2005?
Provide a succinct answer. 1. What is the ratio of the Transition rate(%) of Malaysia in 1999 to that in 2005?
Offer a terse response. 0.98. What is the ratio of the Transition rate(%) in World in 1999 to that in 2006?
Your response must be concise. 0.97. What is the ratio of the Transition rate(%) in Malaysia in 1999 to that in 2006?
Give a very brief answer. 0.98. What is the ratio of the Transition rate(%) in World in 1999 to that in 2007?
Provide a succinct answer. 0.97. What is the ratio of the Transition rate(%) in Hungary in 1999 to that in 2007?
Ensure brevity in your answer.  1. What is the ratio of the Transition rate(%) of Malaysia in 1999 to that in 2007?
Give a very brief answer. 0.98. What is the ratio of the Transition rate(%) of Peru in 1999 to that in 2007?
Offer a very short reply. 1.02. What is the ratio of the Transition rate(%) of World in 1999 to that in 2008?
Your answer should be very brief. 0.97. What is the ratio of the Transition rate(%) in Malaysia in 1999 to that in 2008?
Your response must be concise. 0.98. What is the ratio of the Transition rate(%) of World in 1999 to that in 2009?
Offer a very short reply. 0.97. What is the ratio of the Transition rate(%) of Hungary in 1999 to that in 2009?
Keep it short and to the point. 1. What is the ratio of the Transition rate(%) in Malaysia in 1999 to that in 2009?
Your answer should be very brief. 0.98. What is the ratio of the Transition rate(%) of Peru in 1999 to that in 2009?
Give a very brief answer. 1.01. What is the ratio of the Transition rate(%) of World in 2004 to that in 2005?
Give a very brief answer. 0.99. What is the ratio of the Transition rate(%) in Malaysia in 2004 to that in 2005?
Your answer should be compact. 1. What is the ratio of the Transition rate(%) in Peru in 2004 to that in 2005?
Provide a short and direct response. 1. What is the ratio of the Transition rate(%) in World in 2004 to that in 2006?
Offer a very short reply. 0.99. What is the ratio of the Transition rate(%) of Hungary in 2004 to that in 2006?
Give a very brief answer. 1. What is the ratio of the Transition rate(%) of Malaysia in 2004 to that in 2006?
Provide a short and direct response. 1. What is the ratio of the Transition rate(%) in Peru in 2004 to that in 2006?
Your answer should be very brief. 1. What is the ratio of the Transition rate(%) in Malaysia in 2004 to that in 2007?
Your answer should be compact. 1. What is the ratio of the Transition rate(%) in Peru in 2004 to that in 2007?
Offer a terse response. 1.02. What is the ratio of the Transition rate(%) of World in 2004 to that in 2008?
Your answer should be compact. 0.99. What is the ratio of the Transition rate(%) of Hungary in 2004 to that in 2008?
Your response must be concise. 1. What is the ratio of the Transition rate(%) of Peru in 2004 to that in 2008?
Make the answer very short. 1. What is the ratio of the Transition rate(%) of World in 2004 to that in 2009?
Make the answer very short. 0.99. What is the ratio of the Transition rate(%) in Malaysia in 2004 to that in 2009?
Offer a very short reply. 1. What is the ratio of the Transition rate(%) of Peru in 2004 to that in 2009?
Make the answer very short. 1.02. What is the ratio of the Transition rate(%) in Malaysia in 2005 to that in 2006?
Provide a short and direct response. 1. What is the ratio of the Transition rate(%) of World in 2005 to that in 2007?
Ensure brevity in your answer.  1. What is the ratio of the Transition rate(%) of Malaysia in 2005 to that in 2007?
Provide a succinct answer. 1. What is the ratio of the Transition rate(%) of Peru in 2005 to that in 2007?
Ensure brevity in your answer.  1.03. What is the ratio of the Transition rate(%) in Hungary in 2005 to that in 2008?
Your answer should be very brief. 1. What is the ratio of the Transition rate(%) of Malaysia in 2005 to that in 2008?
Give a very brief answer. 1. What is the ratio of the Transition rate(%) of Peru in 2005 to that in 2008?
Offer a very short reply. 1.01. What is the ratio of the Transition rate(%) of Malaysia in 2005 to that in 2009?
Provide a short and direct response. 1. What is the ratio of the Transition rate(%) of Peru in 2005 to that in 2009?
Keep it short and to the point. 1.02. What is the ratio of the Transition rate(%) of World in 2006 to that in 2007?
Provide a short and direct response. 1.01. What is the ratio of the Transition rate(%) in Hungary in 2006 to that in 2007?
Give a very brief answer. 1. What is the ratio of the Transition rate(%) of Peru in 2006 to that in 2007?
Provide a succinct answer. 1.02. What is the ratio of the Transition rate(%) of Hungary in 2006 to that in 2008?
Make the answer very short. 1. What is the ratio of the Transition rate(%) of Malaysia in 2006 to that in 2008?
Your answer should be very brief. 1. What is the ratio of the Transition rate(%) of World in 2006 to that in 2009?
Make the answer very short. 1.01. What is the ratio of the Transition rate(%) of Malaysia in 2006 to that in 2009?
Provide a succinct answer. 1. What is the ratio of the Transition rate(%) of Peru in 2006 to that in 2009?
Keep it short and to the point. 1.01. What is the ratio of the Transition rate(%) in Malaysia in 2007 to that in 2008?
Keep it short and to the point. 1. What is the ratio of the Transition rate(%) of Peru in 2007 to that in 2008?
Give a very brief answer. 0.98. What is the ratio of the Transition rate(%) of World in 2007 to that in 2009?
Give a very brief answer. 1. What is the ratio of the Transition rate(%) of Hungary in 2007 to that in 2009?
Your answer should be very brief. 1. What is the ratio of the Transition rate(%) in Peru in 2007 to that in 2009?
Your answer should be compact. 0.99. What is the ratio of the Transition rate(%) in Peru in 2008 to that in 2009?
Provide a short and direct response. 1.01. What is the difference between the highest and the second highest Transition rate(%) of World?
Make the answer very short. 0.47. What is the difference between the highest and the second highest Transition rate(%) in Peru?
Offer a terse response. 0.26. What is the difference between the highest and the lowest Transition rate(%) of World?
Provide a succinct answer. 3.87. What is the difference between the highest and the lowest Transition rate(%) of Hungary?
Offer a terse response. 0.35. What is the difference between the highest and the lowest Transition rate(%) in Malaysia?
Provide a short and direct response. 1.86. What is the difference between the highest and the lowest Transition rate(%) of Peru?
Make the answer very short. 2.75. 